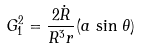<formula> <loc_0><loc_0><loc_500><loc_500>G ^ { 2 } _ { 1 } = \frac { 2 \dot { R } } { R ^ { 3 } r } ( a \, \sin \, \theta )</formula> 